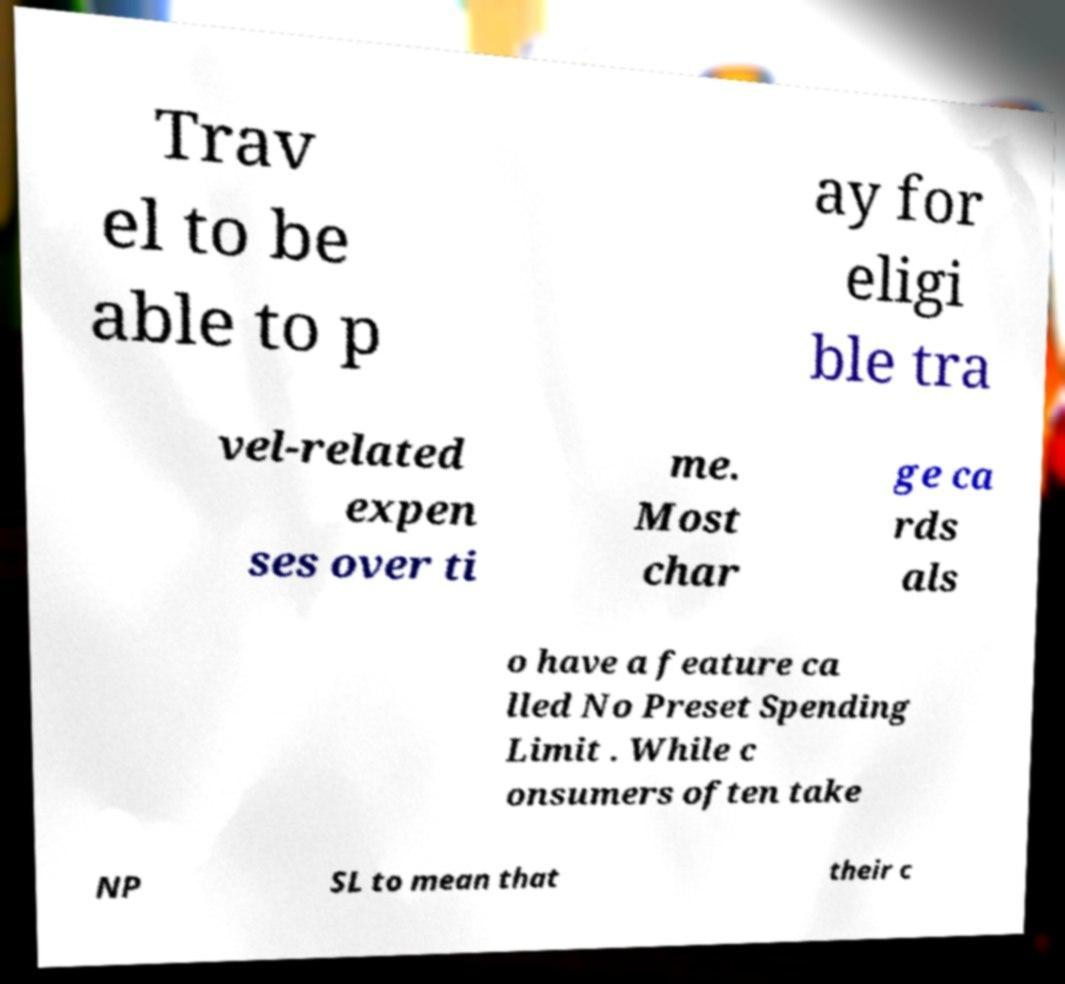Please identify and transcribe the text found in this image. Trav el to be able to p ay for eligi ble tra vel-related expen ses over ti me. Most char ge ca rds als o have a feature ca lled No Preset Spending Limit . While c onsumers often take NP SL to mean that their c 